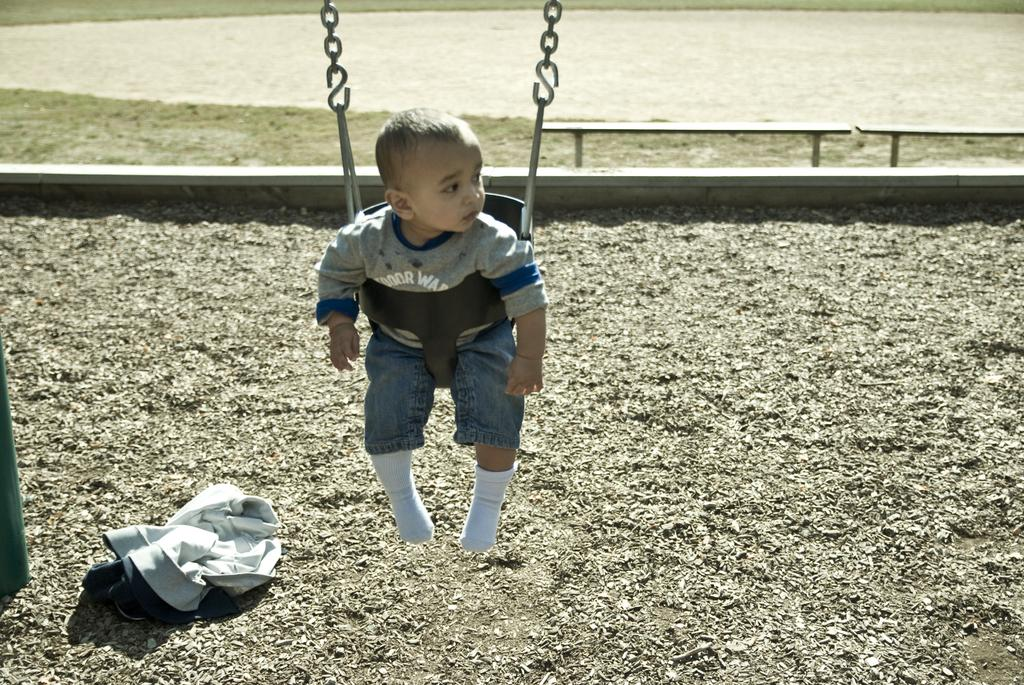What is the kid doing in the image? The kid is sitting on a swing in the image. What is holding up the swing? There is a pole supporting the swing in the image. Are there any other seating options visible in the image? Yes, there are benches in the image. What item is on the ground in the image? There is a jacket on the ground in the image. What type of sofa can be seen in the image? There is no sofa present in the image. How many trains are visible in the image? There are no trains visible in the image. 